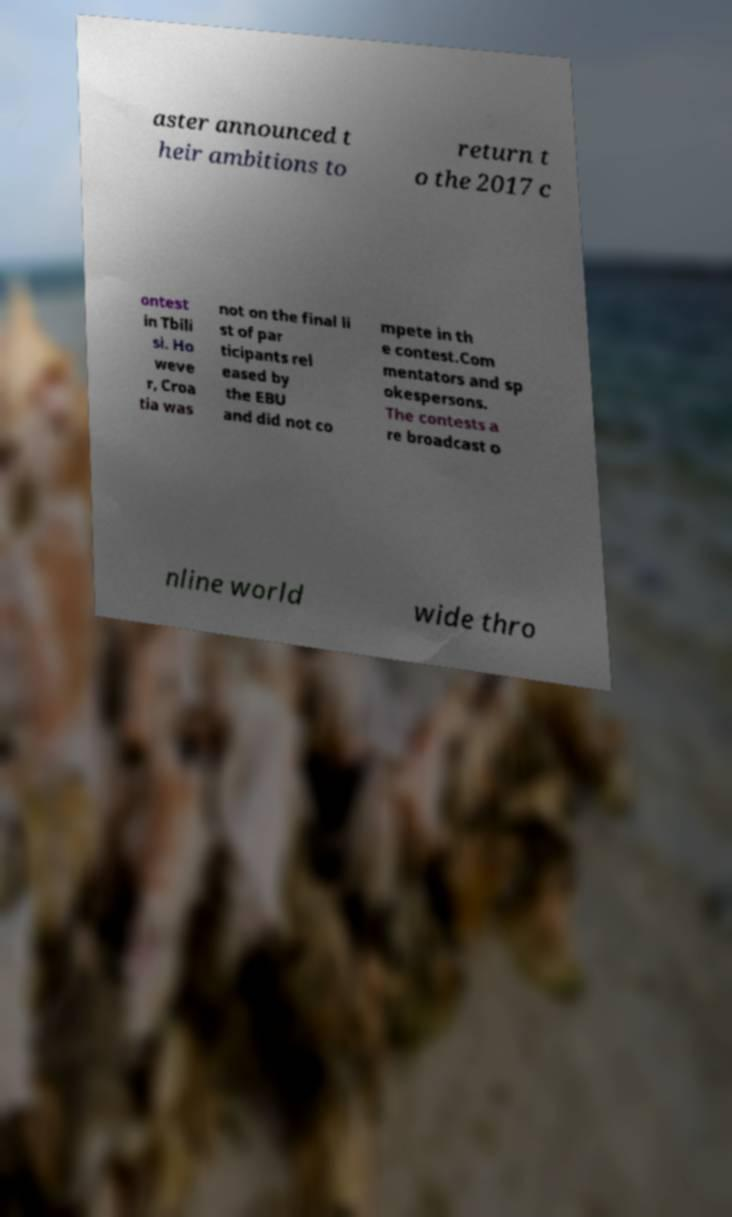Can you accurately transcribe the text from the provided image for me? aster announced t heir ambitions to return t o the 2017 c ontest in Tbili si. Ho weve r, Croa tia was not on the final li st of par ticipants rel eased by the EBU and did not co mpete in th e contest.Com mentators and sp okespersons. The contests a re broadcast o nline world wide thro 